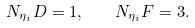<formula> <loc_0><loc_0><loc_500><loc_500>N _ { \eta _ { i } } D = 1 , \quad N _ { \eta _ { i } } F = 3 .</formula> 